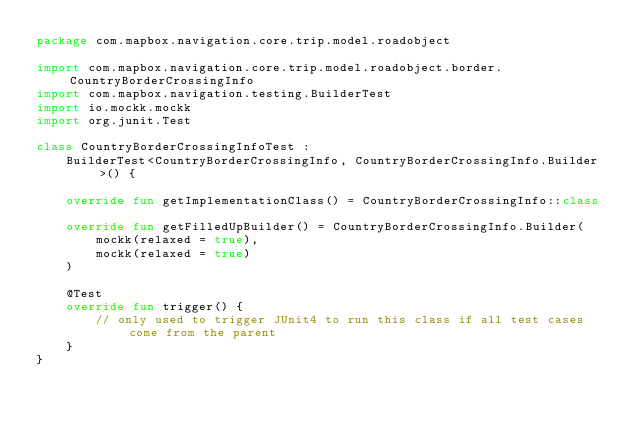<code> <loc_0><loc_0><loc_500><loc_500><_Kotlin_>package com.mapbox.navigation.core.trip.model.roadobject

import com.mapbox.navigation.core.trip.model.roadobject.border.CountryBorderCrossingInfo
import com.mapbox.navigation.testing.BuilderTest
import io.mockk.mockk
import org.junit.Test

class CountryBorderCrossingInfoTest :
    BuilderTest<CountryBorderCrossingInfo, CountryBorderCrossingInfo.Builder>() {

    override fun getImplementationClass() = CountryBorderCrossingInfo::class

    override fun getFilledUpBuilder() = CountryBorderCrossingInfo.Builder(
        mockk(relaxed = true),
        mockk(relaxed = true)
    )

    @Test
    override fun trigger() {
        // only used to trigger JUnit4 to run this class if all test cases come from the parent
    }
}
</code> 